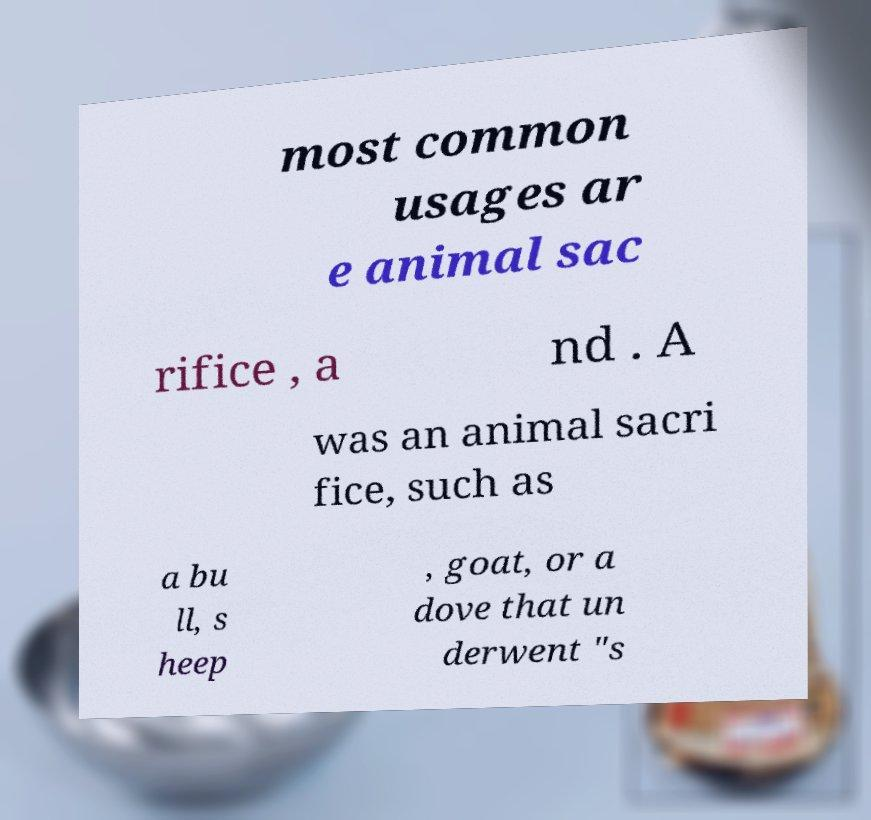What messages or text are displayed in this image? I need them in a readable, typed format. most common usages ar e animal sac rifice , a nd . A was an animal sacri fice, such as a bu ll, s heep , goat, or a dove that un derwent "s 